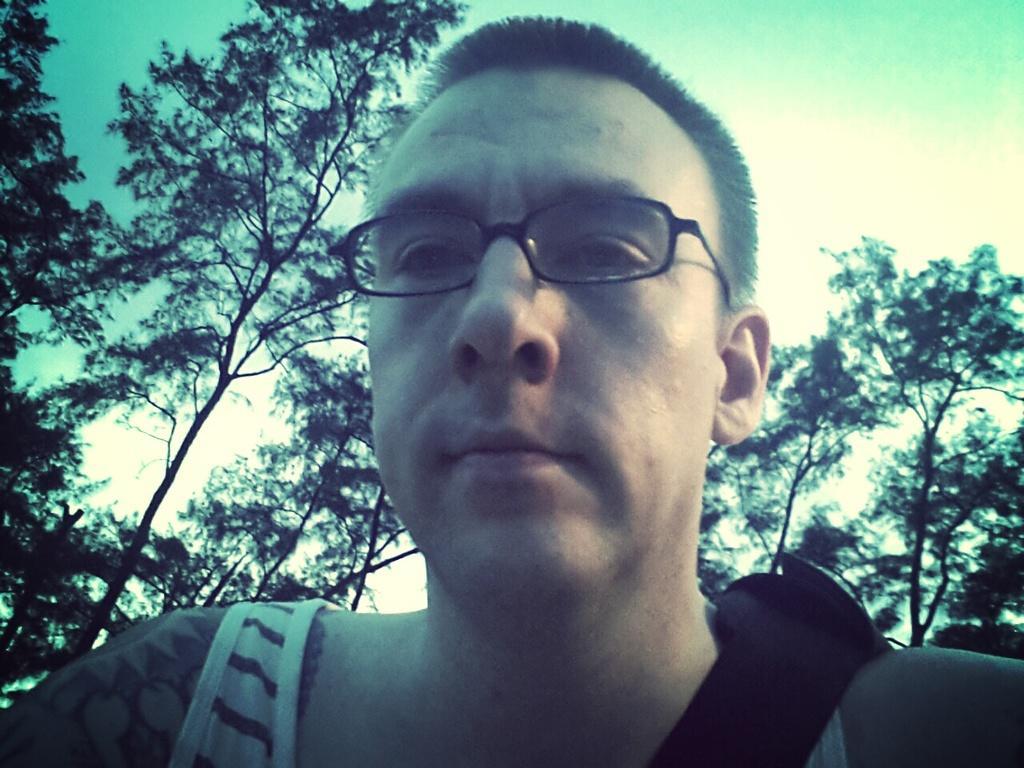How would you summarize this image in a sentence or two? This image is taken outdoors. At the top of the image there is the sky. In the background there are a few trees with leaves, stems and branches. In the middle of the image there is a man. 